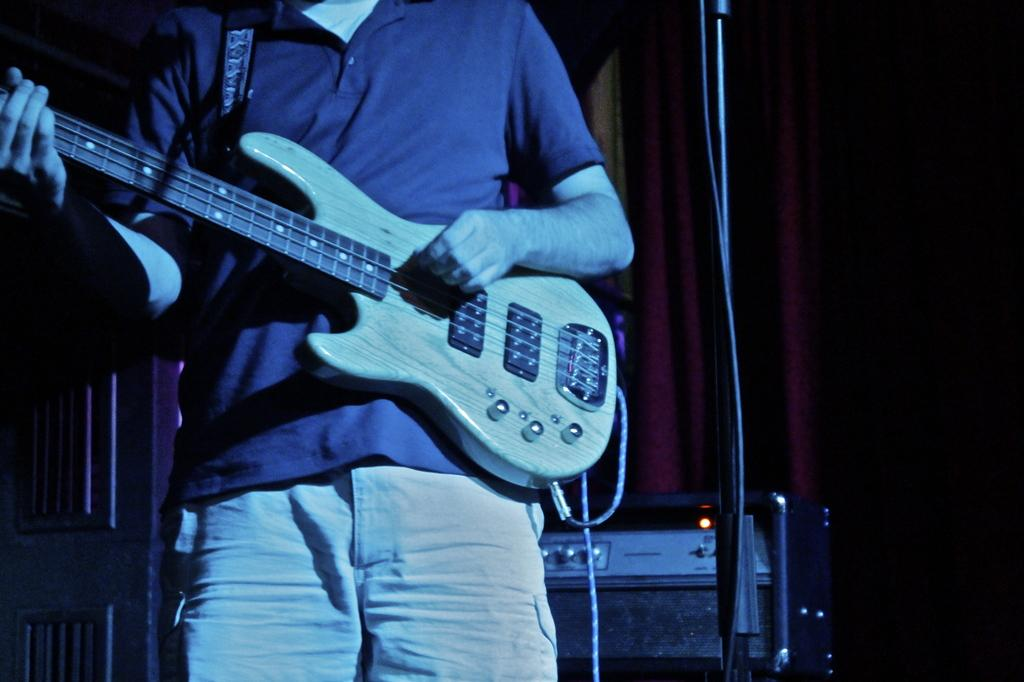What is the man in the image doing? The man is playing a guitar. How is the man positioned in the image? The man is standing. What can be seen behind the man in the image? There is a device behind the man. What type of background element is present in the image? There is a red curtain in the image. What scientific discovery is the man making while playing the guitar in the image? There is no indication of a scientific discovery being made in the image; the man is simply playing a guitar. 